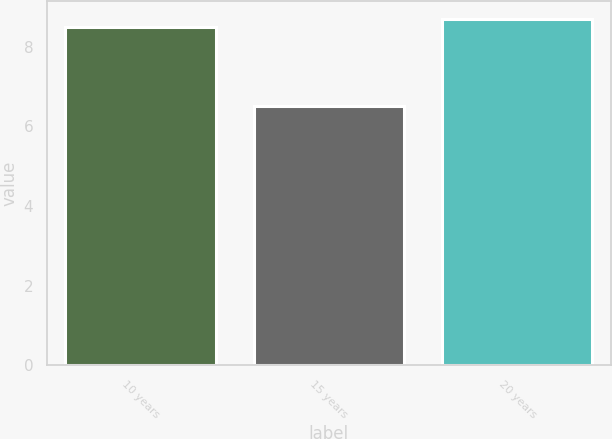Convert chart. <chart><loc_0><loc_0><loc_500><loc_500><bar_chart><fcel>10 years<fcel>15 years<fcel>20 years<nl><fcel>8.5<fcel>6.5<fcel>8.7<nl></chart> 